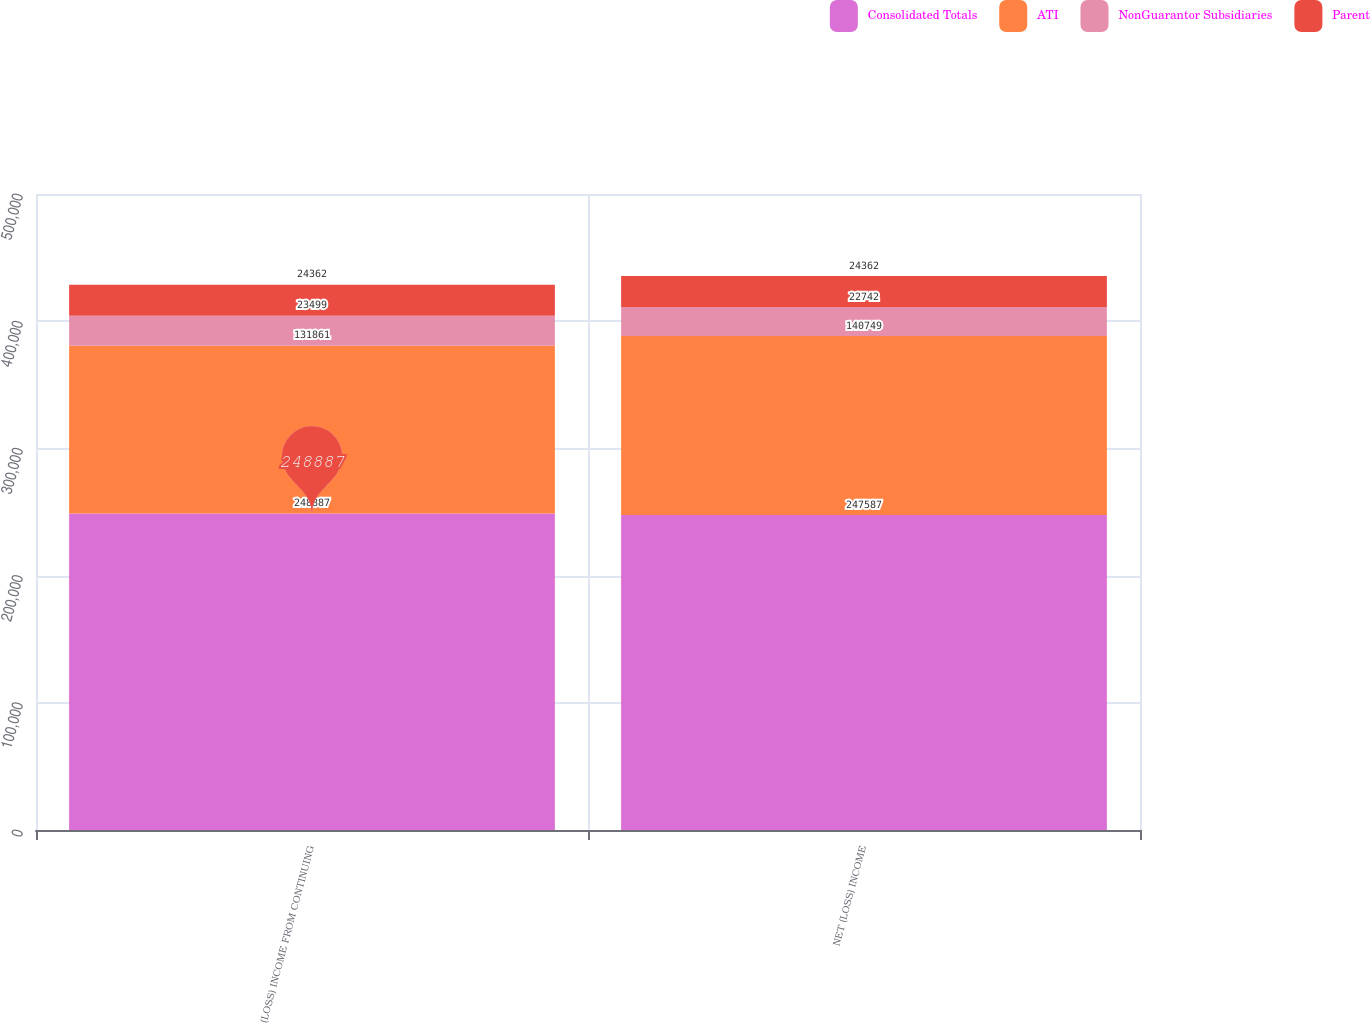Convert chart to OTSL. <chart><loc_0><loc_0><loc_500><loc_500><stacked_bar_chart><ecel><fcel>(LOSS) INCOME FROM CONTINUING<fcel>NET (LOSS) INCOME<nl><fcel>Consolidated Totals<fcel>248887<fcel>247587<nl><fcel>ATI<fcel>131861<fcel>140749<nl><fcel>NonGuarantor Subsidiaries<fcel>23499<fcel>22742<nl><fcel>Parent<fcel>24362<fcel>24362<nl></chart> 